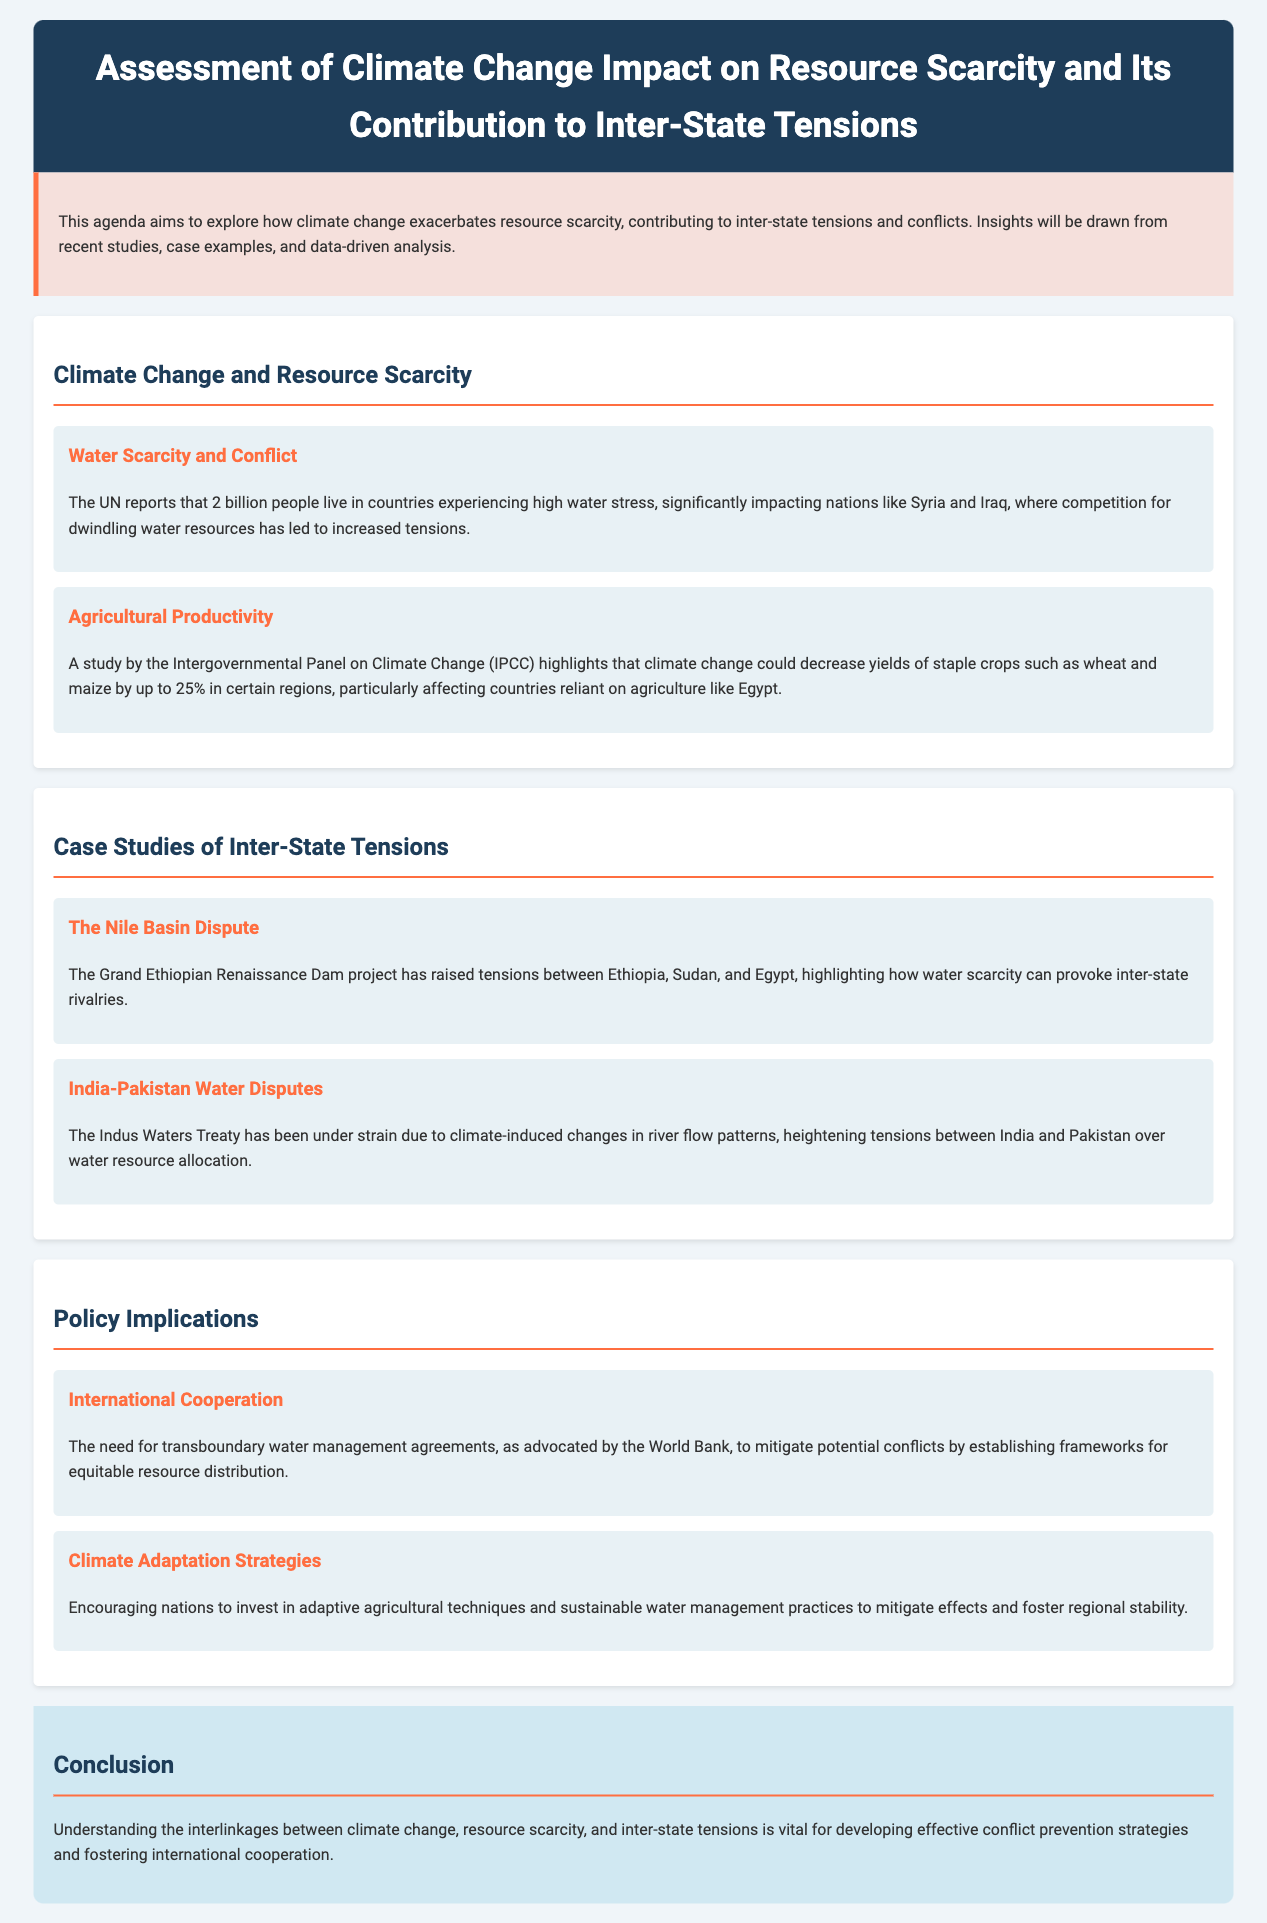What is the main focus of the agenda? The document's introduction specifies that the agenda aims to explore the impact of climate change on resource scarcity and its contribution to inter-state tensions and conflicts.
Answer: Climate change impact on resource scarcity and inter-state tensions How many people live in countries experiencing high water stress? The document notes that the UN reports 2 billion people live in countries experiencing high water stress.
Answer: 2 billion Which countries are mentioned as being affected by competition for water resources? The document cites Syria and Iraq as nations where competition for dwindling water resources has led to increased tensions.
Answer: Syria and Iraq What is one of the key agricultural crops that may see yield decreases due to climate change? The document mentions wheat as one of the staple crops that could see decreased yields because of climate change.
Answer: Wheat Which project has raised tensions between Ethiopia, Sudan, and Egypt? The Grand Ethiopian Renaissance Dam project is highlighted in the document as causing tensions between these nations.
Answer: Grand Ethiopian Renaissance Dam What treaty is mentioned as being under strain due to climate-induced changes? The Indus Waters Treaty is referred to in the document regarding its strain due to river flow changes linked to climate.
Answer: Indus Waters Treaty What is one proposed strategy for international cooperation? The document advocates for transboundary water management agreements to mitigate potential conflicts.
Answer: Transboundary water management agreements What do the key points in the policy implications section focus on? The key points concentrate on international cooperation and climate adaptation strategies as measures to address resource scarcity and inter-state tensions.
Answer: International cooperation and climate adaptation strategies 